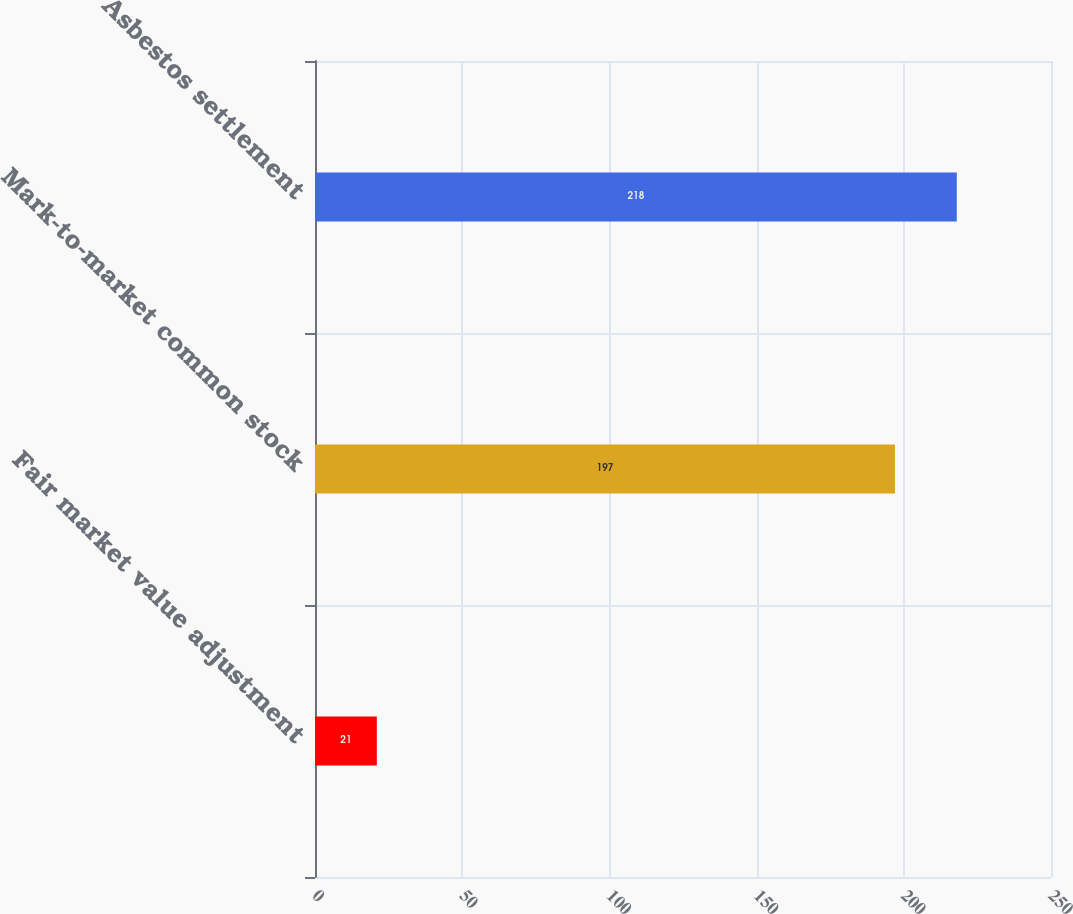Convert chart. <chart><loc_0><loc_0><loc_500><loc_500><bar_chart><fcel>Fair market value adjustment<fcel>Mark-to-market common stock<fcel>Asbestos settlement<nl><fcel>21<fcel>197<fcel>218<nl></chart> 